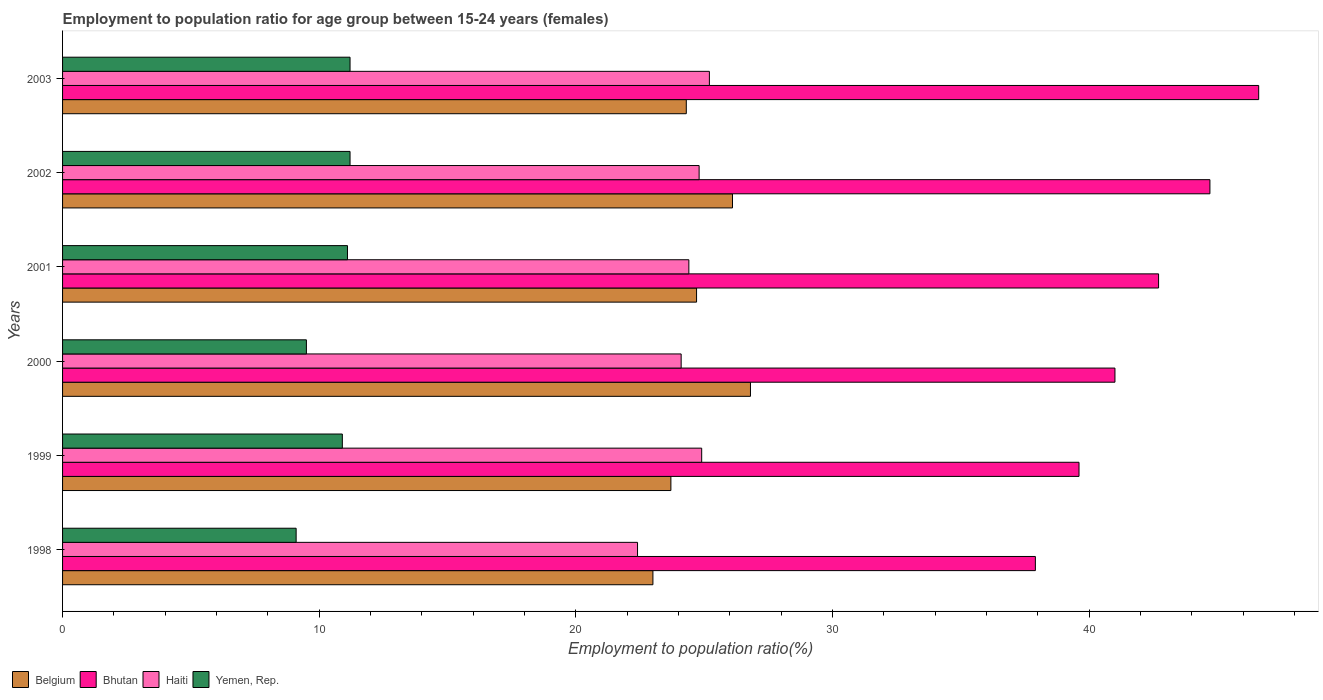Are the number of bars per tick equal to the number of legend labels?
Your answer should be very brief. Yes. Are the number of bars on each tick of the Y-axis equal?
Provide a short and direct response. Yes. How many bars are there on the 1st tick from the top?
Your response must be concise. 4. How many bars are there on the 4th tick from the bottom?
Give a very brief answer. 4. What is the label of the 3rd group of bars from the top?
Offer a terse response. 2001. In how many cases, is the number of bars for a given year not equal to the number of legend labels?
Give a very brief answer. 0. What is the employment to population ratio in Bhutan in 2001?
Keep it short and to the point. 42.7. Across all years, what is the maximum employment to population ratio in Belgium?
Your answer should be very brief. 26.8. Across all years, what is the minimum employment to population ratio in Yemen, Rep.?
Offer a very short reply. 9.1. In which year was the employment to population ratio in Haiti maximum?
Offer a very short reply. 2003. In which year was the employment to population ratio in Yemen, Rep. minimum?
Offer a very short reply. 1998. What is the total employment to population ratio in Bhutan in the graph?
Your answer should be very brief. 252.5. What is the difference between the employment to population ratio in Belgium in 1999 and that in 2003?
Keep it short and to the point. -0.6. What is the difference between the employment to population ratio in Belgium in 2000 and the employment to population ratio in Bhutan in 2001?
Provide a short and direct response. -15.9. What is the average employment to population ratio in Belgium per year?
Give a very brief answer. 24.77. In the year 1999, what is the difference between the employment to population ratio in Bhutan and employment to population ratio in Yemen, Rep.?
Offer a terse response. 28.7. In how many years, is the employment to population ratio in Belgium greater than 16 %?
Ensure brevity in your answer.  6. What is the ratio of the employment to population ratio in Yemen, Rep. in 2001 to that in 2002?
Provide a succinct answer. 0.99. What is the difference between the highest and the second highest employment to population ratio in Haiti?
Provide a succinct answer. 0.3. What is the difference between the highest and the lowest employment to population ratio in Haiti?
Your answer should be compact. 2.8. In how many years, is the employment to population ratio in Bhutan greater than the average employment to population ratio in Bhutan taken over all years?
Offer a terse response. 3. Is the sum of the employment to population ratio in Belgium in 2000 and 2002 greater than the maximum employment to population ratio in Haiti across all years?
Your answer should be compact. Yes. Is it the case that in every year, the sum of the employment to population ratio in Belgium and employment to population ratio in Haiti is greater than the sum of employment to population ratio in Yemen, Rep. and employment to population ratio in Bhutan?
Your response must be concise. Yes. What does the 4th bar from the top in 2001 represents?
Offer a very short reply. Belgium. What does the 1st bar from the bottom in 2002 represents?
Your response must be concise. Belgium. Is it the case that in every year, the sum of the employment to population ratio in Bhutan and employment to population ratio in Yemen, Rep. is greater than the employment to population ratio in Belgium?
Give a very brief answer. Yes. How many bars are there?
Your answer should be compact. 24. Are all the bars in the graph horizontal?
Make the answer very short. Yes. What is the difference between two consecutive major ticks on the X-axis?
Your answer should be very brief. 10. Does the graph contain any zero values?
Provide a short and direct response. No. Does the graph contain grids?
Your answer should be very brief. No. Where does the legend appear in the graph?
Make the answer very short. Bottom left. How are the legend labels stacked?
Keep it short and to the point. Horizontal. What is the title of the graph?
Keep it short and to the point. Employment to population ratio for age group between 15-24 years (females). Does "Syrian Arab Republic" appear as one of the legend labels in the graph?
Your response must be concise. No. What is the label or title of the X-axis?
Provide a succinct answer. Employment to population ratio(%). What is the Employment to population ratio(%) in Belgium in 1998?
Keep it short and to the point. 23. What is the Employment to population ratio(%) of Bhutan in 1998?
Your answer should be compact. 37.9. What is the Employment to population ratio(%) in Haiti in 1998?
Your response must be concise. 22.4. What is the Employment to population ratio(%) of Yemen, Rep. in 1998?
Provide a short and direct response. 9.1. What is the Employment to population ratio(%) of Belgium in 1999?
Make the answer very short. 23.7. What is the Employment to population ratio(%) of Bhutan in 1999?
Give a very brief answer. 39.6. What is the Employment to population ratio(%) of Haiti in 1999?
Offer a terse response. 24.9. What is the Employment to population ratio(%) of Yemen, Rep. in 1999?
Provide a succinct answer. 10.9. What is the Employment to population ratio(%) in Belgium in 2000?
Provide a succinct answer. 26.8. What is the Employment to population ratio(%) of Haiti in 2000?
Your answer should be very brief. 24.1. What is the Employment to population ratio(%) of Belgium in 2001?
Offer a terse response. 24.7. What is the Employment to population ratio(%) in Bhutan in 2001?
Provide a succinct answer. 42.7. What is the Employment to population ratio(%) in Haiti in 2001?
Provide a short and direct response. 24.4. What is the Employment to population ratio(%) in Yemen, Rep. in 2001?
Provide a short and direct response. 11.1. What is the Employment to population ratio(%) in Belgium in 2002?
Make the answer very short. 26.1. What is the Employment to population ratio(%) of Bhutan in 2002?
Provide a succinct answer. 44.7. What is the Employment to population ratio(%) in Haiti in 2002?
Provide a short and direct response. 24.8. What is the Employment to population ratio(%) in Yemen, Rep. in 2002?
Your response must be concise. 11.2. What is the Employment to population ratio(%) of Belgium in 2003?
Keep it short and to the point. 24.3. What is the Employment to population ratio(%) of Bhutan in 2003?
Make the answer very short. 46.6. What is the Employment to population ratio(%) in Haiti in 2003?
Provide a succinct answer. 25.2. What is the Employment to population ratio(%) of Yemen, Rep. in 2003?
Provide a short and direct response. 11.2. Across all years, what is the maximum Employment to population ratio(%) of Belgium?
Offer a very short reply. 26.8. Across all years, what is the maximum Employment to population ratio(%) in Bhutan?
Give a very brief answer. 46.6. Across all years, what is the maximum Employment to population ratio(%) in Haiti?
Give a very brief answer. 25.2. Across all years, what is the maximum Employment to population ratio(%) of Yemen, Rep.?
Give a very brief answer. 11.2. Across all years, what is the minimum Employment to population ratio(%) in Belgium?
Offer a terse response. 23. Across all years, what is the minimum Employment to population ratio(%) in Bhutan?
Your answer should be compact. 37.9. Across all years, what is the minimum Employment to population ratio(%) of Haiti?
Offer a terse response. 22.4. Across all years, what is the minimum Employment to population ratio(%) in Yemen, Rep.?
Your response must be concise. 9.1. What is the total Employment to population ratio(%) of Belgium in the graph?
Offer a very short reply. 148.6. What is the total Employment to population ratio(%) of Bhutan in the graph?
Offer a terse response. 252.5. What is the total Employment to population ratio(%) of Haiti in the graph?
Make the answer very short. 145.8. What is the difference between the Employment to population ratio(%) of Bhutan in 1998 and that in 1999?
Provide a short and direct response. -1.7. What is the difference between the Employment to population ratio(%) in Haiti in 1998 and that in 1999?
Offer a terse response. -2.5. What is the difference between the Employment to population ratio(%) in Yemen, Rep. in 1998 and that in 1999?
Give a very brief answer. -1.8. What is the difference between the Employment to population ratio(%) of Belgium in 1998 and that in 2000?
Keep it short and to the point. -3.8. What is the difference between the Employment to population ratio(%) in Bhutan in 1998 and that in 2000?
Provide a succinct answer. -3.1. What is the difference between the Employment to population ratio(%) in Yemen, Rep. in 1998 and that in 2000?
Your answer should be very brief. -0.4. What is the difference between the Employment to population ratio(%) of Yemen, Rep. in 1998 and that in 2001?
Give a very brief answer. -2. What is the difference between the Employment to population ratio(%) in Belgium in 1998 and that in 2002?
Make the answer very short. -3.1. What is the difference between the Employment to population ratio(%) in Yemen, Rep. in 1998 and that in 2002?
Provide a short and direct response. -2.1. What is the difference between the Employment to population ratio(%) of Haiti in 1998 and that in 2003?
Give a very brief answer. -2.8. What is the difference between the Employment to population ratio(%) of Belgium in 1999 and that in 2000?
Ensure brevity in your answer.  -3.1. What is the difference between the Employment to population ratio(%) of Haiti in 1999 and that in 2000?
Provide a succinct answer. 0.8. What is the difference between the Employment to population ratio(%) of Yemen, Rep. in 1999 and that in 2000?
Offer a terse response. 1.4. What is the difference between the Employment to population ratio(%) in Bhutan in 1999 and that in 2001?
Give a very brief answer. -3.1. What is the difference between the Employment to population ratio(%) in Yemen, Rep. in 1999 and that in 2001?
Offer a terse response. -0.2. What is the difference between the Employment to population ratio(%) in Yemen, Rep. in 1999 and that in 2002?
Your answer should be very brief. -0.3. What is the difference between the Employment to population ratio(%) of Bhutan in 1999 and that in 2003?
Give a very brief answer. -7. What is the difference between the Employment to population ratio(%) of Yemen, Rep. in 1999 and that in 2003?
Offer a terse response. -0.3. What is the difference between the Employment to population ratio(%) in Bhutan in 2000 and that in 2001?
Keep it short and to the point. -1.7. What is the difference between the Employment to population ratio(%) in Haiti in 2000 and that in 2001?
Provide a short and direct response. -0.3. What is the difference between the Employment to population ratio(%) of Belgium in 2000 and that in 2002?
Ensure brevity in your answer.  0.7. What is the difference between the Employment to population ratio(%) of Haiti in 2000 and that in 2002?
Give a very brief answer. -0.7. What is the difference between the Employment to population ratio(%) in Belgium in 2000 and that in 2003?
Offer a very short reply. 2.5. What is the difference between the Employment to population ratio(%) in Bhutan in 2000 and that in 2003?
Your answer should be very brief. -5.6. What is the difference between the Employment to population ratio(%) of Haiti in 2000 and that in 2003?
Ensure brevity in your answer.  -1.1. What is the difference between the Employment to population ratio(%) in Belgium in 2001 and that in 2002?
Your answer should be very brief. -1.4. What is the difference between the Employment to population ratio(%) of Bhutan in 2001 and that in 2002?
Your answer should be compact. -2. What is the difference between the Employment to population ratio(%) of Haiti in 2001 and that in 2003?
Your response must be concise. -0.8. What is the difference between the Employment to population ratio(%) of Yemen, Rep. in 2001 and that in 2003?
Offer a terse response. -0.1. What is the difference between the Employment to population ratio(%) of Belgium in 2002 and that in 2003?
Offer a very short reply. 1.8. What is the difference between the Employment to population ratio(%) of Bhutan in 2002 and that in 2003?
Ensure brevity in your answer.  -1.9. What is the difference between the Employment to population ratio(%) of Haiti in 2002 and that in 2003?
Your answer should be very brief. -0.4. What is the difference between the Employment to population ratio(%) in Belgium in 1998 and the Employment to population ratio(%) in Bhutan in 1999?
Your response must be concise. -16.6. What is the difference between the Employment to population ratio(%) in Belgium in 1998 and the Employment to population ratio(%) in Yemen, Rep. in 1999?
Keep it short and to the point. 12.1. What is the difference between the Employment to population ratio(%) in Bhutan in 1998 and the Employment to population ratio(%) in Haiti in 1999?
Your response must be concise. 13. What is the difference between the Employment to population ratio(%) of Haiti in 1998 and the Employment to population ratio(%) of Yemen, Rep. in 1999?
Give a very brief answer. 11.5. What is the difference between the Employment to population ratio(%) of Belgium in 1998 and the Employment to population ratio(%) of Bhutan in 2000?
Your answer should be very brief. -18. What is the difference between the Employment to population ratio(%) in Bhutan in 1998 and the Employment to population ratio(%) in Yemen, Rep. in 2000?
Provide a succinct answer. 28.4. What is the difference between the Employment to population ratio(%) of Haiti in 1998 and the Employment to population ratio(%) of Yemen, Rep. in 2000?
Offer a very short reply. 12.9. What is the difference between the Employment to population ratio(%) of Belgium in 1998 and the Employment to population ratio(%) of Bhutan in 2001?
Offer a terse response. -19.7. What is the difference between the Employment to population ratio(%) in Belgium in 1998 and the Employment to population ratio(%) in Haiti in 2001?
Your answer should be compact. -1.4. What is the difference between the Employment to population ratio(%) of Bhutan in 1998 and the Employment to population ratio(%) of Haiti in 2001?
Make the answer very short. 13.5. What is the difference between the Employment to population ratio(%) of Bhutan in 1998 and the Employment to population ratio(%) of Yemen, Rep. in 2001?
Provide a succinct answer. 26.8. What is the difference between the Employment to population ratio(%) of Haiti in 1998 and the Employment to population ratio(%) of Yemen, Rep. in 2001?
Provide a succinct answer. 11.3. What is the difference between the Employment to population ratio(%) of Belgium in 1998 and the Employment to population ratio(%) of Bhutan in 2002?
Provide a succinct answer. -21.7. What is the difference between the Employment to population ratio(%) of Belgium in 1998 and the Employment to population ratio(%) of Haiti in 2002?
Offer a very short reply. -1.8. What is the difference between the Employment to population ratio(%) in Bhutan in 1998 and the Employment to population ratio(%) in Yemen, Rep. in 2002?
Give a very brief answer. 26.7. What is the difference between the Employment to population ratio(%) of Belgium in 1998 and the Employment to population ratio(%) of Bhutan in 2003?
Provide a short and direct response. -23.6. What is the difference between the Employment to population ratio(%) of Belgium in 1998 and the Employment to population ratio(%) of Yemen, Rep. in 2003?
Your answer should be compact. 11.8. What is the difference between the Employment to population ratio(%) in Bhutan in 1998 and the Employment to population ratio(%) in Haiti in 2003?
Your response must be concise. 12.7. What is the difference between the Employment to population ratio(%) of Bhutan in 1998 and the Employment to population ratio(%) of Yemen, Rep. in 2003?
Your response must be concise. 26.7. What is the difference between the Employment to population ratio(%) in Belgium in 1999 and the Employment to population ratio(%) in Bhutan in 2000?
Give a very brief answer. -17.3. What is the difference between the Employment to population ratio(%) of Belgium in 1999 and the Employment to population ratio(%) of Yemen, Rep. in 2000?
Keep it short and to the point. 14.2. What is the difference between the Employment to population ratio(%) of Bhutan in 1999 and the Employment to population ratio(%) of Yemen, Rep. in 2000?
Make the answer very short. 30.1. What is the difference between the Employment to population ratio(%) in Haiti in 1999 and the Employment to population ratio(%) in Yemen, Rep. in 2000?
Your answer should be compact. 15.4. What is the difference between the Employment to population ratio(%) in Belgium in 1999 and the Employment to population ratio(%) in Yemen, Rep. in 2001?
Provide a succinct answer. 12.6. What is the difference between the Employment to population ratio(%) of Bhutan in 1999 and the Employment to population ratio(%) of Haiti in 2001?
Offer a terse response. 15.2. What is the difference between the Employment to population ratio(%) of Belgium in 1999 and the Employment to population ratio(%) of Bhutan in 2002?
Give a very brief answer. -21. What is the difference between the Employment to population ratio(%) of Belgium in 1999 and the Employment to population ratio(%) of Haiti in 2002?
Your response must be concise. -1.1. What is the difference between the Employment to population ratio(%) of Belgium in 1999 and the Employment to population ratio(%) of Yemen, Rep. in 2002?
Offer a terse response. 12.5. What is the difference between the Employment to population ratio(%) of Bhutan in 1999 and the Employment to population ratio(%) of Yemen, Rep. in 2002?
Your response must be concise. 28.4. What is the difference between the Employment to population ratio(%) of Belgium in 1999 and the Employment to population ratio(%) of Bhutan in 2003?
Ensure brevity in your answer.  -22.9. What is the difference between the Employment to population ratio(%) in Belgium in 1999 and the Employment to population ratio(%) in Haiti in 2003?
Provide a short and direct response. -1.5. What is the difference between the Employment to population ratio(%) in Belgium in 1999 and the Employment to population ratio(%) in Yemen, Rep. in 2003?
Give a very brief answer. 12.5. What is the difference between the Employment to population ratio(%) of Bhutan in 1999 and the Employment to population ratio(%) of Haiti in 2003?
Provide a short and direct response. 14.4. What is the difference between the Employment to population ratio(%) in Bhutan in 1999 and the Employment to population ratio(%) in Yemen, Rep. in 2003?
Keep it short and to the point. 28.4. What is the difference between the Employment to population ratio(%) in Belgium in 2000 and the Employment to population ratio(%) in Bhutan in 2001?
Make the answer very short. -15.9. What is the difference between the Employment to population ratio(%) of Bhutan in 2000 and the Employment to population ratio(%) of Haiti in 2001?
Offer a very short reply. 16.6. What is the difference between the Employment to population ratio(%) in Bhutan in 2000 and the Employment to population ratio(%) in Yemen, Rep. in 2001?
Your answer should be compact. 29.9. What is the difference between the Employment to population ratio(%) of Haiti in 2000 and the Employment to population ratio(%) of Yemen, Rep. in 2001?
Keep it short and to the point. 13. What is the difference between the Employment to population ratio(%) in Belgium in 2000 and the Employment to population ratio(%) in Bhutan in 2002?
Give a very brief answer. -17.9. What is the difference between the Employment to population ratio(%) in Belgium in 2000 and the Employment to population ratio(%) in Haiti in 2002?
Give a very brief answer. 2. What is the difference between the Employment to population ratio(%) of Bhutan in 2000 and the Employment to population ratio(%) of Yemen, Rep. in 2002?
Offer a very short reply. 29.8. What is the difference between the Employment to population ratio(%) in Haiti in 2000 and the Employment to population ratio(%) in Yemen, Rep. in 2002?
Your answer should be compact. 12.9. What is the difference between the Employment to population ratio(%) in Belgium in 2000 and the Employment to population ratio(%) in Bhutan in 2003?
Your answer should be very brief. -19.8. What is the difference between the Employment to population ratio(%) of Belgium in 2000 and the Employment to population ratio(%) of Haiti in 2003?
Offer a terse response. 1.6. What is the difference between the Employment to population ratio(%) in Belgium in 2000 and the Employment to population ratio(%) in Yemen, Rep. in 2003?
Offer a very short reply. 15.6. What is the difference between the Employment to population ratio(%) of Bhutan in 2000 and the Employment to population ratio(%) of Yemen, Rep. in 2003?
Provide a short and direct response. 29.8. What is the difference between the Employment to population ratio(%) of Haiti in 2000 and the Employment to population ratio(%) of Yemen, Rep. in 2003?
Ensure brevity in your answer.  12.9. What is the difference between the Employment to population ratio(%) in Belgium in 2001 and the Employment to population ratio(%) in Bhutan in 2002?
Offer a terse response. -20. What is the difference between the Employment to population ratio(%) in Belgium in 2001 and the Employment to population ratio(%) in Haiti in 2002?
Offer a very short reply. -0.1. What is the difference between the Employment to population ratio(%) in Bhutan in 2001 and the Employment to population ratio(%) in Yemen, Rep. in 2002?
Your answer should be very brief. 31.5. What is the difference between the Employment to population ratio(%) in Haiti in 2001 and the Employment to population ratio(%) in Yemen, Rep. in 2002?
Provide a succinct answer. 13.2. What is the difference between the Employment to population ratio(%) of Belgium in 2001 and the Employment to population ratio(%) of Bhutan in 2003?
Your answer should be very brief. -21.9. What is the difference between the Employment to population ratio(%) in Belgium in 2001 and the Employment to population ratio(%) in Haiti in 2003?
Provide a short and direct response. -0.5. What is the difference between the Employment to population ratio(%) of Bhutan in 2001 and the Employment to population ratio(%) of Haiti in 2003?
Provide a succinct answer. 17.5. What is the difference between the Employment to population ratio(%) in Bhutan in 2001 and the Employment to population ratio(%) in Yemen, Rep. in 2003?
Make the answer very short. 31.5. What is the difference between the Employment to population ratio(%) of Haiti in 2001 and the Employment to population ratio(%) of Yemen, Rep. in 2003?
Your answer should be very brief. 13.2. What is the difference between the Employment to population ratio(%) of Belgium in 2002 and the Employment to population ratio(%) of Bhutan in 2003?
Provide a short and direct response. -20.5. What is the difference between the Employment to population ratio(%) in Belgium in 2002 and the Employment to population ratio(%) in Yemen, Rep. in 2003?
Ensure brevity in your answer.  14.9. What is the difference between the Employment to population ratio(%) of Bhutan in 2002 and the Employment to population ratio(%) of Yemen, Rep. in 2003?
Offer a terse response. 33.5. What is the difference between the Employment to population ratio(%) of Haiti in 2002 and the Employment to population ratio(%) of Yemen, Rep. in 2003?
Keep it short and to the point. 13.6. What is the average Employment to population ratio(%) in Belgium per year?
Your answer should be very brief. 24.77. What is the average Employment to population ratio(%) in Bhutan per year?
Offer a terse response. 42.08. What is the average Employment to population ratio(%) in Haiti per year?
Your answer should be compact. 24.3. In the year 1998, what is the difference between the Employment to population ratio(%) of Belgium and Employment to population ratio(%) of Bhutan?
Your response must be concise. -14.9. In the year 1998, what is the difference between the Employment to population ratio(%) in Belgium and Employment to population ratio(%) in Yemen, Rep.?
Ensure brevity in your answer.  13.9. In the year 1998, what is the difference between the Employment to population ratio(%) of Bhutan and Employment to population ratio(%) of Haiti?
Offer a terse response. 15.5. In the year 1998, what is the difference between the Employment to population ratio(%) of Bhutan and Employment to population ratio(%) of Yemen, Rep.?
Give a very brief answer. 28.8. In the year 1999, what is the difference between the Employment to population ratio(%) in Belgium and Employment to population ratio(%) in Bhutan?
Offer a very short reply. -15.9. In the year 1999, what is the difference between the Employment to population ratio(%) of Belgium and Employment to population ratio(%) of Yemen, Rep.?
Ensure brevity in your answer.  12.8. In the year 1999, what is the difference between the Employment to population ratio(%) in Bhutan and Employment to population ratio(%) in Haiti?
Your answer should be very brief. 14.7. In the year 1999, what is the difference between the Employment to population ratio(%) in Bhutan and Employment to population ratio(%) in Yemen, Rep.?
Offer a very short reply. 28.7. In the year 1999, what is the difference between the Employment to population ratio(%) in Haiti and Employment to population ratio(%) in Yemen, Rep.?
Provide a short and direct response. 14. In the year 2000, what is the difference between the Employment to population ratio(%) of Belgium and Employment to population ratio(%) of Bhutan?
Give a very brief answer. -14.2. In the year 2000, what is the difference between the Employment to population ratio(%) in Belgium and Employment to population ratio(%) in Haiti?
Offer a terse response. 2.7. In the year 2000, what is the difference between the Employment to population ratio(%) of Bhutan and Employment to population ratio(%) of Haiti?
Your answer should be very brief. 16.9. In the year 2000, what is the difference between the Employment to population ratio(%) of Bhutan and Employment to population ratio(%) of Yemen, Rep.?
Your answer should be compact. 31.5. In the year 2000, what is the difference between the Employment to population ratio(%) in Haiti and Employment to population ratio(%) in Yemen, Rep.?
Your answer should be very brief. 14.6. In the year 2001, what is the difference between the Employment to population ratio(%) of Belgium and Employment to population ratio(%) of Yemen, Rep.?
Provide a succinct answer. 13.6. In the year 2001, what is the difference between the Employment to population ratio(%) of Bhutan and Employment to population ratio(%) of Yemen, Rep.?
Your answer should be very brief. 31.6. In the year 2002, what is the difference between the Employment to population ratio(%) of Belgium and Employment to population ratio(%) of Bhutan?
Provide a short and direct response. -18.6. In the year 2002, what is the difference between the Employment to population ratio(%) in Belgium and Employment to population ratio(%) in Haiti?
Keep it short and to the point. 1.3. In the year 2002, what is the difference between the Employment to population ratio(%) of Belgium and Employment to population ratio(%) of Yemen, Rep.?
Keep it short and to the point. 14.9. In the year 2002, what is the difference between the Employment to population ratio(%) in Bhutan and Employment to population ratio(%) in Yemen, Rep.?
Give a very brief answer. 33.5. In the year 2002, what is the difference between the Employment to population ratio(%) of Haiti and Employment to population ratio(%) of Yemen, Rep.?
Your response must be concise. 13.6. In the year 2003, what is the difference between the Employment to population ratio(%) in Belgium and Employment to population ratio(%) in Bhutan?
Your answer should be very brief. -22.3. In the year 2003, what is the difference between the Employment to population ratio(%) in Belgium and Employment to population ratio(%) in Haiti?
Offer a terse response. -0.9. In the year 2003, what is the difference between the Employment to population ratio(%) of Belgium and Employment to population ratio(%) of Yemen, Rep.?
Ensure brevity in your answer.  13.1. In the year 2003, what is the difference between the Employment to population ratio(%) in Bhutan and Employment to population ratio(%) in Haiti?
Provide a short and direct response. 21.4. In the year 2003, what is the difference between the Employment to population ratio(%) in Bhutan and Employment to population ratio(%) in Yemen, Rep.?
Provide a succinct answer. 35.4. In the year 2003, what is the difference between the Employment to population ratio(%) in Haiti and Employment to population ratio(%) in Yemen, Rep.?
Your answer should be compact. 14. What is the ratio of the Employment to population ratio(%) of Belgium in 1998 to that in 1999?
Provide a succinct answer. 0.97. What is the ratio of the Employment to population ratio(%) of Bhutan in 1998 to that in 1999?
Your response must be concise. 0.96. What is the ratio of the Employment to population ratio(%) of Haiti in 1998 to that in 1999?
Your answer should be very brief. 0.9. What is the ratio of the Employment to population ratio(%) in Yemen, Rep. in 1998 to that in 1999?
Your answer should be compact. 0.83. What is the ratio of the Employment to population ratio(%) of Belgium in 1998 to that in 2000?
Make the answer very short. 0.86. What is the ratio of the Employment to population ratio(%) in Bhutan in 1998 to that in 2000?
Your response must be concise. 0.92. What is the ratio of the Employment to population ratio(%) in Haiti in 1998 to that in 2000?
Offer a terse response. 0.93. What is the ratio of the Employment to population ratio(%) in Yemen, Rep. in 1998 to that in 2000?
Offer a very short reply. 0.96. What is the ratio of the Employment to population ratio(%) in Belgium in 1998 to that in 2001?
Your answer should be compact. 0.93. What is the ratio of the Employment to population ratio(%) in Bhutan in 1998 to that in 2001?
Make the answer very short. 0.89. What is the ratio of the Employment to population ratio(%) of Haiti in 1998 to that in 2001?
Provide a succinct answer. 0.92. What is the ratio of the Employment to population ratio(%) of Yemen, Rep. in 1998 to that in 2001?
Provide a succinct answer. 0.82. What is the ratio of the Employment to population ratio(%) in Belgium in 1998 to that in 2002?
Offer a very short reply. 0.88. What is the ratio of the Employment to population ratio(%) of Bhutan in 1998 to that in 2002?
Your answer should be compact. 0.85. What is the ratio of the Employment to population ratio(%) in Haiti in 1998 to that in 2002?
Your answer should be compact. 0.9. What is the ratio of the Employment to population ratio(%) of Yemen, Rep. in 1998 to that in 2002?
Offer a terse response. 0.81. What is the ratio of the Employment to population ratio(%) of Belgium in 1998 to that in 2003?
Provide a succinct answer. 0.95. What is the ratio of the Employment to population ratio(%) of Bhutan in 1998 to that in 2003?
Your answer should be compact. 0.81. What is the ratio of the Employment to population ratio(%) in Yemen, Rep. in 1998 to that in 2003?
Keep it short and to the point. 0.81. What is the ratio of the Employment to population ratio(%) of Belgium in 1999 to that in 2000?
Give a very brief answer. 0.88. What is the ratio of the Employment to population ratio(%) in Bhutan in 1999 to that in 2000?
Your answer should be very brief. 0.97. What is the ratio of the Employment to population ratio(%) in Haiti in 1999 to that in 2000?
Provide a succinct answer. 1.03. What is the ratio of the Employment to population ratio(%) of Yemen, Rep. in 1999 to that in 2000?
Your answer should be very brief. 1.15. What is the ratio of the Employment to population ratio(%) in Belgium in 1999 to that in 2001?
Offer a terse response. 0.96. What is the ratio of the Employment to population ratio(%) in Bhutan in 1999 to that in 2001?
Your response must be concise. 0.93. What is the ratio of the Employment to population ratio(%) in Haiti in 1999 to that in 2001?
Offer a very short reply. 1.02. What is the ratio of the Employment to population ratio(%) of Yemen, Rep. in 1999 to that in 2001?
Keep it short and to the point. 0.98. What is the ratio of the Employment to population ratio(%) of Belgium in 1999 to that in 2002?
Your response must be concise. 0.91. What is the ratio of the Employment to population ratio(%) in Bhutan in 1999 to that in 2002?
Provide a short and direct response. 0.89. What is the ratio of the Employment to population ratio(%) in Yemen, Rep. in 1999 to that in 2002?
Ensure brevity in your answer.  0.97. What is the ratio of the Employment to population ratio(%) of Belgium in 1999 to that in 2003?
Make the answer very short. 0.98. What is the ratio of the Employment to population ratio(%) of Bhutan in 1999 to that in 2003?
Your answer should be very brief. 0.85. What is the ratio of the Employment to population ratio(%) of Haiti in 1999 to that in 2003?
Keep it short and to the point. 0.99. What is the ratio of the Employment to population ratio(%) in Yemen, Rep. in 1999 to that in 2003?
Provide a succinct answer. 0.97. What is the ratio of the Employment to population ratio(%) in Belgium in 2000 to that in 2001?
Your response must be concise. 1.08. What is the ratio of the Employment to population ratio(%) of Bhutan in 2000 to that in 2001?
Your answer should be compact. 0.96. What is the ratio of the Employment to population ratio(%) of Yemen, Rep. in 2000 to that in 2001?
Offer a terse response. 0.86. What is the ratio of the Employment to population ratio(%) of Belgium in 2000 to that in 2002?
Your answer should be very brief. 1.03. What is the ratio of the Employment to population ratio(%) in Bhutan in 2000 to that in 2002?
Offer a terse response. 0.92. What is the ratio of the Employment to population ratio(%) in Haiti in 2000 to that in 2002?
Give a very brief answer. 0.97. What is the ratio of the Employment to population ratio(%) of Yemen, Rep. in 2000 to that in 2002?
Make the answer very short. 0.85. What is the ratio of the Employment to population ratio(%) in Belgium in 2000 to that in 2003?
Provide a succinct answer. 1.1. What is the ratio of the Employment to population ratio(%) in Bhutan in 2000 to that in 2003?
Your response must be concise. 0.88. What is the ratio of the Employment to population ratio(%) in Haiti in 2000 to that in 2003?
Offer a very short reply. 0.96. What is the ratio of the Employment to population ratio(%) in Yemen, Rep. in 2000 to that in 2003?
Keep it short and to the point. 0.85. What is the ratio of the Employment to population ratio(%) in Belgium in 2001 to that in 2002?
Offer a terse response. 0.95. What is the ratio of the Employment to population ratio(%) of Bhutan in 2001 to that in 2002?
Offer a terse response. 0.96. What is the ratio of the Employment to population ratio(%) in Haiti in 2001 to that in 2002?
Your answer should be compact. 0.98. What is the ratio of the Employment to population ratio(%) in Belgium in 2001 to that in 2003?
Your answer should be very brief. 1.02. What is the ratio of the Employment to population ratio(%) of Bhutan in 2001 to that in 2003?
Offer a terse response. 0.92. What is the ratio of the Employment to population ratio(%) in Haiti in 2001 to that in 2003?
Provide a short and direct response. 0.97. What is the ratio of the Employment to population ratio(%) of Yemen, Rep. in 2001 to that in 2003?
Your answer should be compact. 0.99. What is the ratio of the Employment to population ratio(%) of Belgium in 2002 to that in 2003?
Your answer should be very brief. 1.07. What is the ratio of the Employment to population ratio(%) of Bhutan in 2002 to that in 2003?
Keep it short and to the point. 0.96. What is the ratio of the Employment to population ratio(%) of Haiti in 2002 to that in 2003?
Ensure brevity in your answer.  0.98. What is the difference between the highest and the lowest Employment to population ratio(%) in Bhutan?
Ensure brevity in your answer.  8.7. What is the difference between the highest and the lowest Employment to population ratio(%) of Yemen, Rep.?
Your answer should be compact. 2.1. 